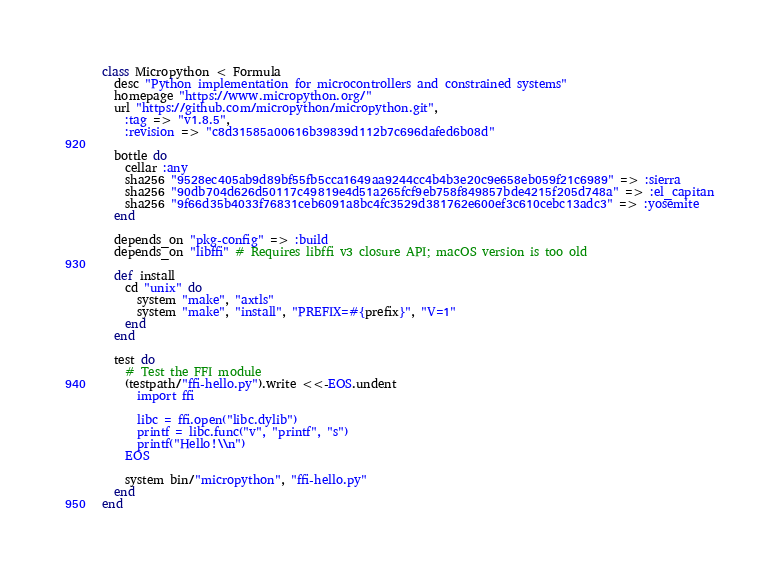Convert code to text. <code><loc_0><loc_0><loc_500><loc_500><_Ruby_>class Micropython < Formula
  desc "Python implementation for microcontrollers and constrained systems"
  homepage "https://www.micropython.org/"
  url "https://github.com/micropython/micropython.git",
    :tag => "v1.8.5",
    :revision => "c8d31585a00616b39839d112b7c696dafed6b08d"

  bottle do
    cellar :any
    sha256 "9528ec405ab9d89bf55fb5cca1649aa9244cc4b4b3e20c9e658eb059f21c6989" => :sierra
    sha256 "90db704d626d50117c49819e4d51a265fcf9eb758f849857bde4215f205d748a" => :el_capitan
    sha256 "9f66d35b4033f76831ceb6091a8bc4fc3529d381762e600ef3c610cebc13adc3" => :yosemite
  end

  depends_on "pkg-config" => :build
  depends_on "libffi" # Requires libffi v3 closure API; macOS version is too old

  def install
    cd "unix" do
      system "make", "axtls"
      system "make", "install", "PREFIX=#{prefix}", "V=1"
    end
  end

  test do
    # Test the FFI module
    (testpath/"ffi-hello.py").write <<-EOS.undent
      import ffi

      libc = ffi.open("libc.dylib")
      printf = libc.func("v", "printf", "s")
      printf("Hello!\\n")
    EOS

    system bin/"micropython", "ffi-hello.py"
  end
end
</code> 